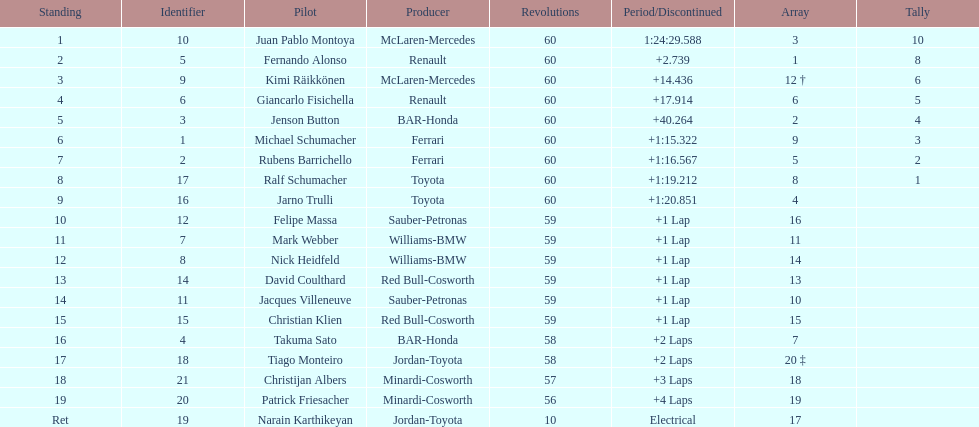Which driver has his grid at 2? Jenson Button. 